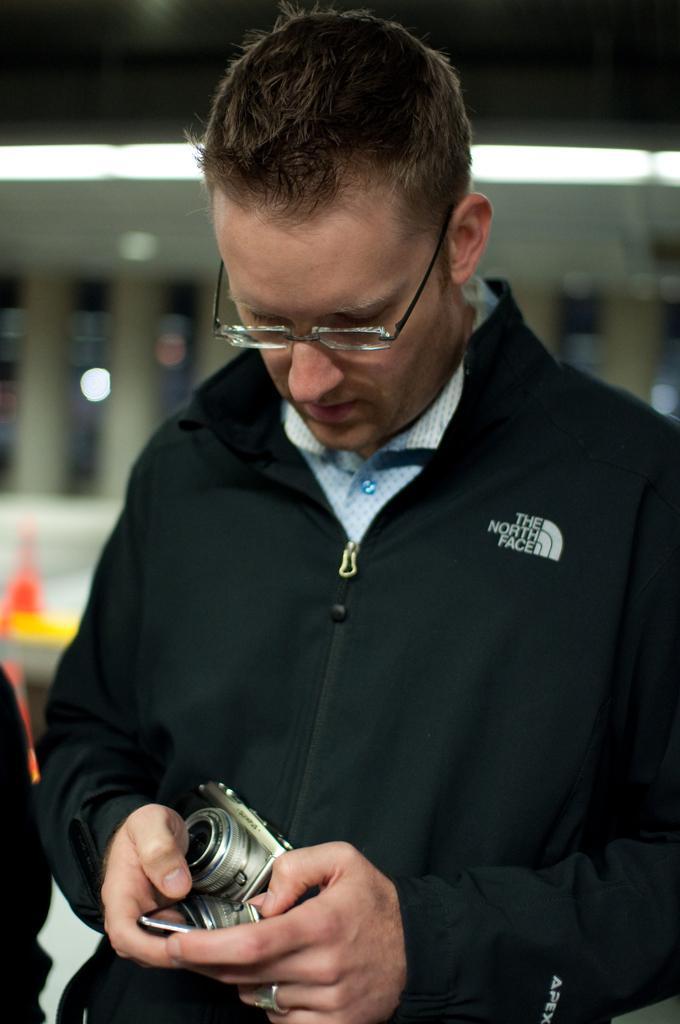Please provide a concise description of this image. In this image we can see a man wearing specs. He is holding camera and a mobile. In the background it is blur. 